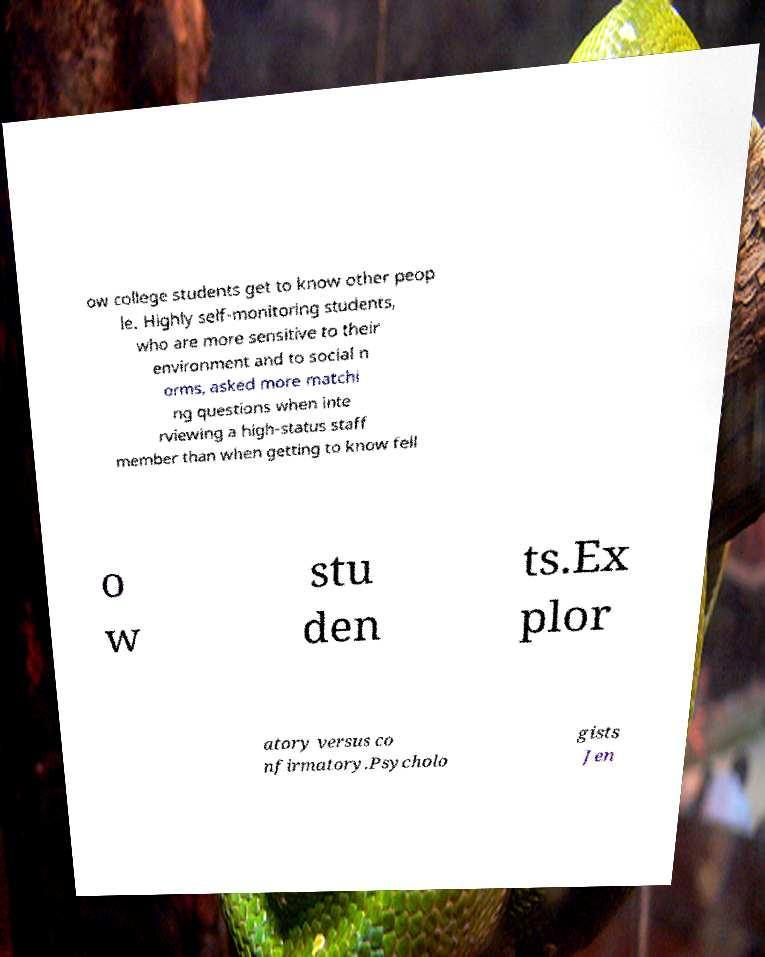What messages or text are displayed in this image? I need them in a readable, typed format. ow college students get to know other peop le. Highly self-monitoring students, who are more sensitive to their environment and to social n orms, asked more matchi ng questions when inte rviewing a high-status staff member than when getting to know fell o w stu den ts.Ex plor atory versus co nfirmatory.Psycholo gists Jen 